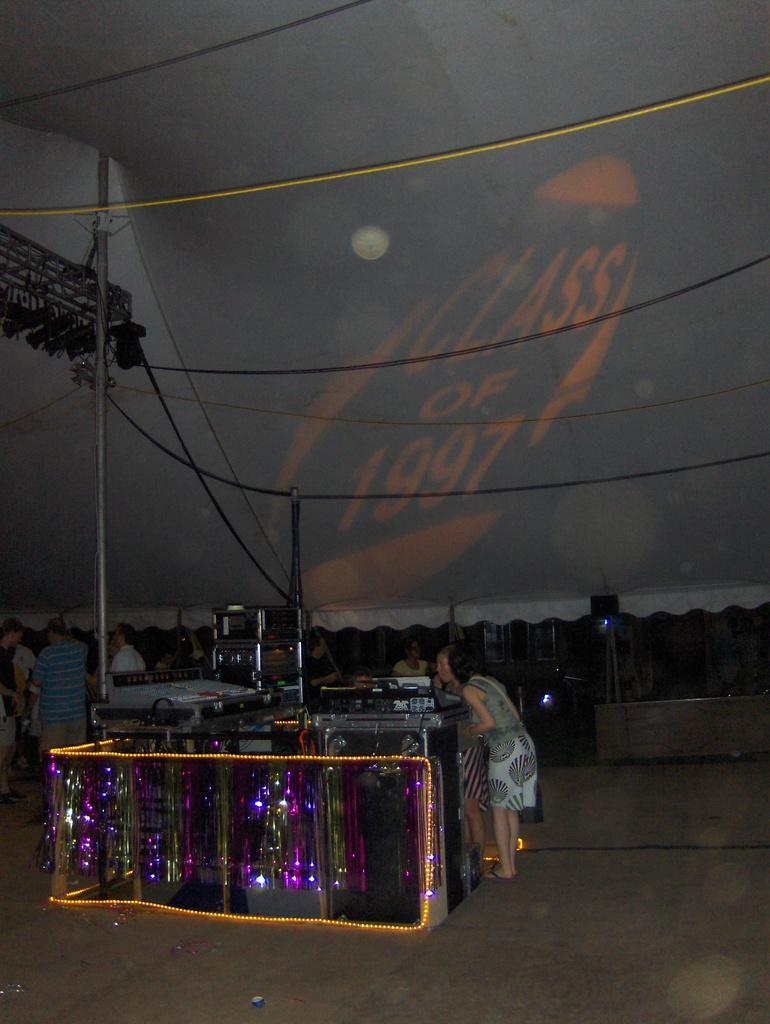In one or two sentences, can you explain what this image depicts? In this image there are a few people standing under the tent. Around them there are few objects decorated with lights. There is a pole and a rope. Over the tent there is some text. 